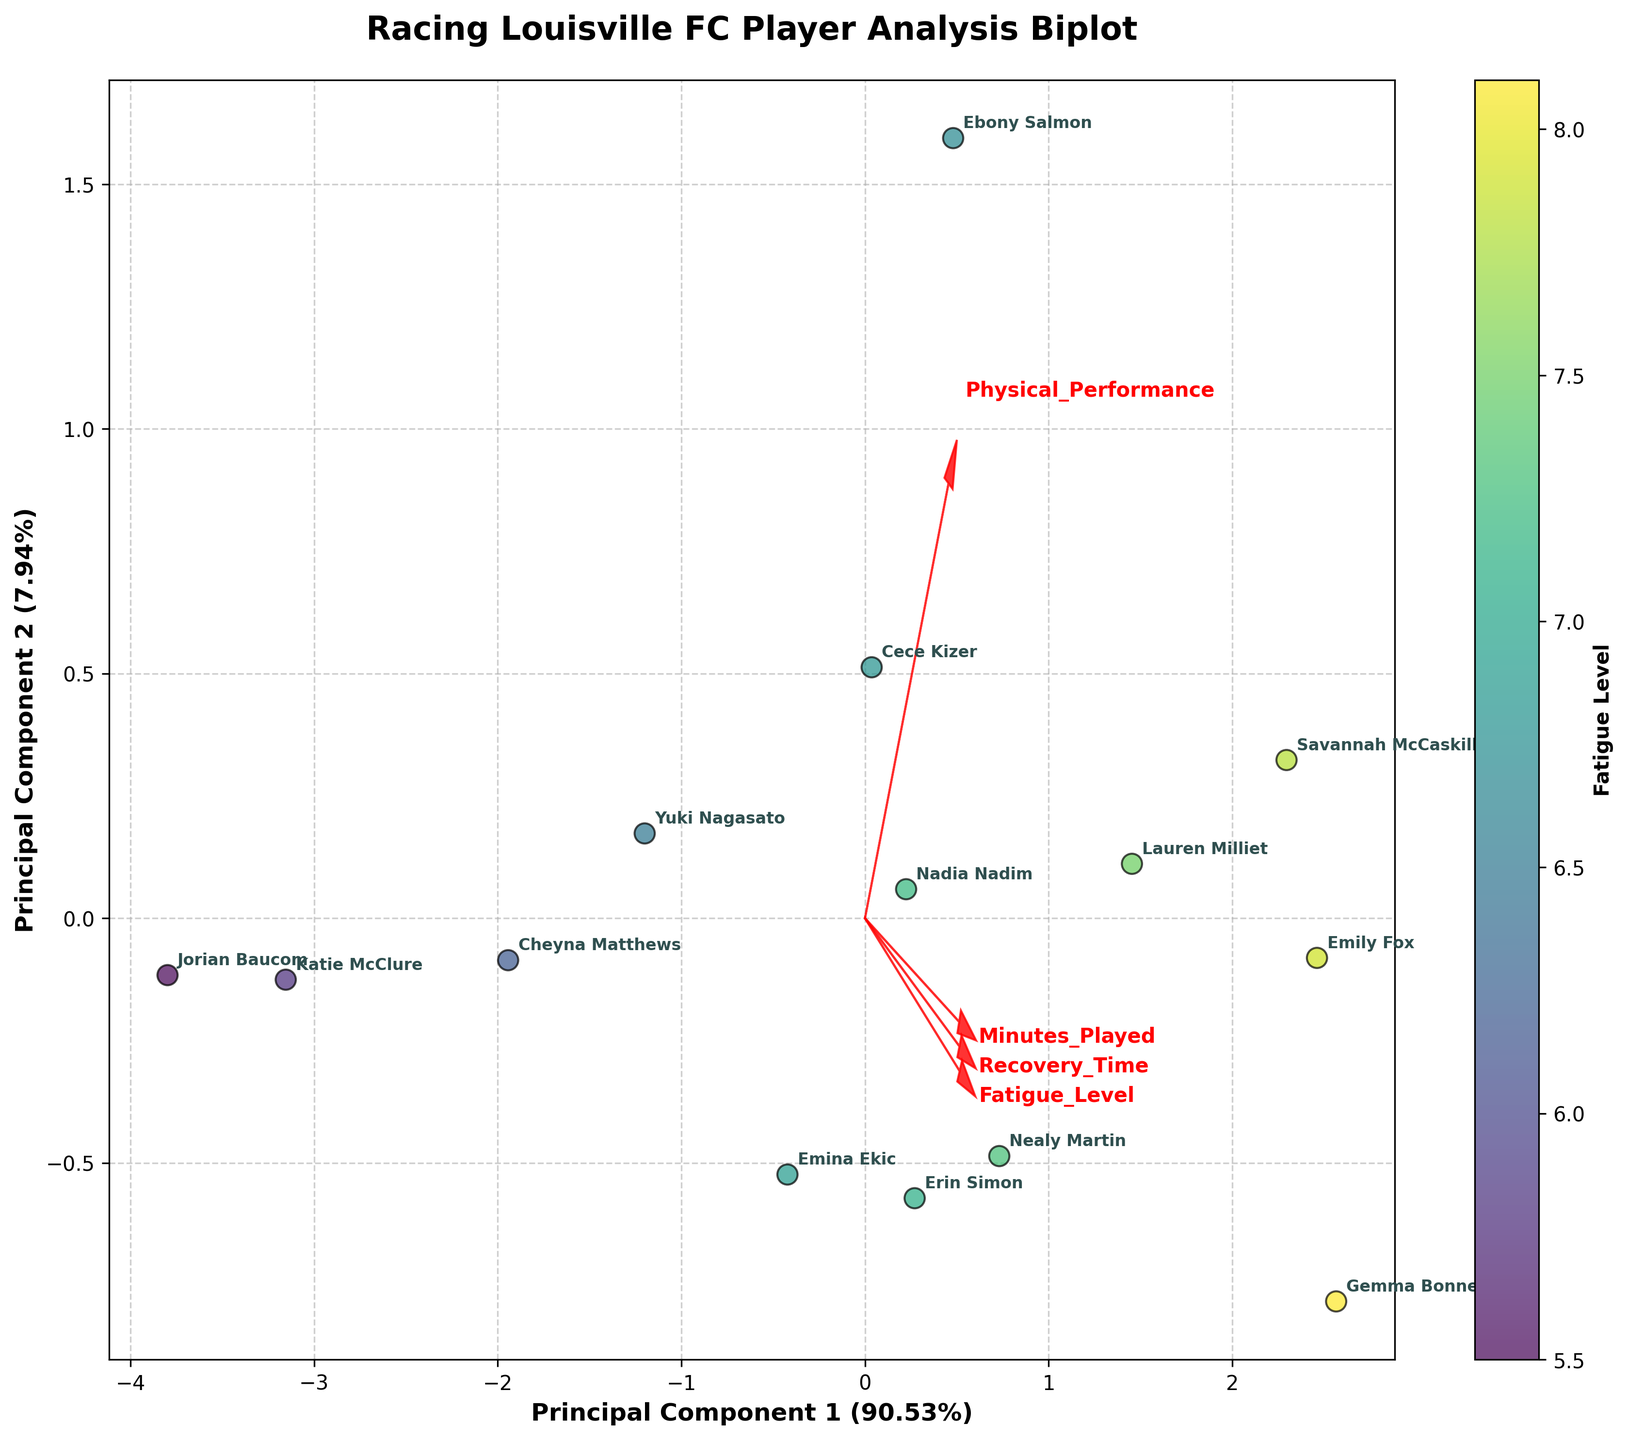Which player has the highest fatigue level? By examining the color gradient associated with fatigue levels in the scatter plot, we see that Gemma Bonner has the highest fatigue level, as indicated by the intensity of the coloration around her data point.
Answer: Gemma Bonner Which axis represents the Principal Component 1? The label on the horizontal axis shows "Principal Component 1" along with the percentage of variance it explains, which makes it clear that the horizontal axis represents Principal Component 1.
Answer: Horizontal axis How are players with higher "Minutes Played" distributed in the plot? Players with higher "Minutes Played" tend to cluster toward one direction influenced by the length and direction of the feature vector corresponding to "Minutes Played."
Answer: Toward one side of the vector Which feature appears to have the strongest influence on Principal Component 1? By observing the feature vectors superimposed on the biplot, we can see that the vector for "Minutes Played" has the greatest projection along Principal Component 1, indicating its strong influence on this component.
Answer: Minutes Played Which player appears closest to the origin in the biplot? The player closest to the origin can be identified by looking at the annotated points near (0,0). Jorian Baucom's marker appears closest to this point.
Answer: Jorian Baucom Which feature has the smallest arrow, indicating the least contribution to the principal components? The length of the arrow for "Recovery Time" is shortest compared to other features, indicating it has the least contribution to the principal components.
Answer: Recovery Time Are minutes played and fatigue level positively correlated according to the biplot? The directions of the arrows for "Minutes Played" and "Fatigue Level" are relatively aligned, indicating a positive correlation between these two variables.
Answer: Yes Between Emina Ekic and Nealy Martin, who has a higher physical performance score? By looking at the data points and their annotations, we find Nealy Martin positioned closer to the direction of the "Physical Performance" vector, suggesting a higher score.
Answer: Nealy Martin Is there any player whose data point lies near the end of the "Physical Performance" arrow? If so, who? By observing the scatter plot, Ebony Salmon’s data point lies near the endpoint of the "Physical Performance" arrow, indicating a high score in that metric.
Answer: Ebony Salmon What percentage of the total variance is explained by Principal Component 2? By reading the label on the vertical axis, which shows "Principal Component 2," the accompanying percentage indicates how much it explains of the total variance.
Answer: ~23.47% 